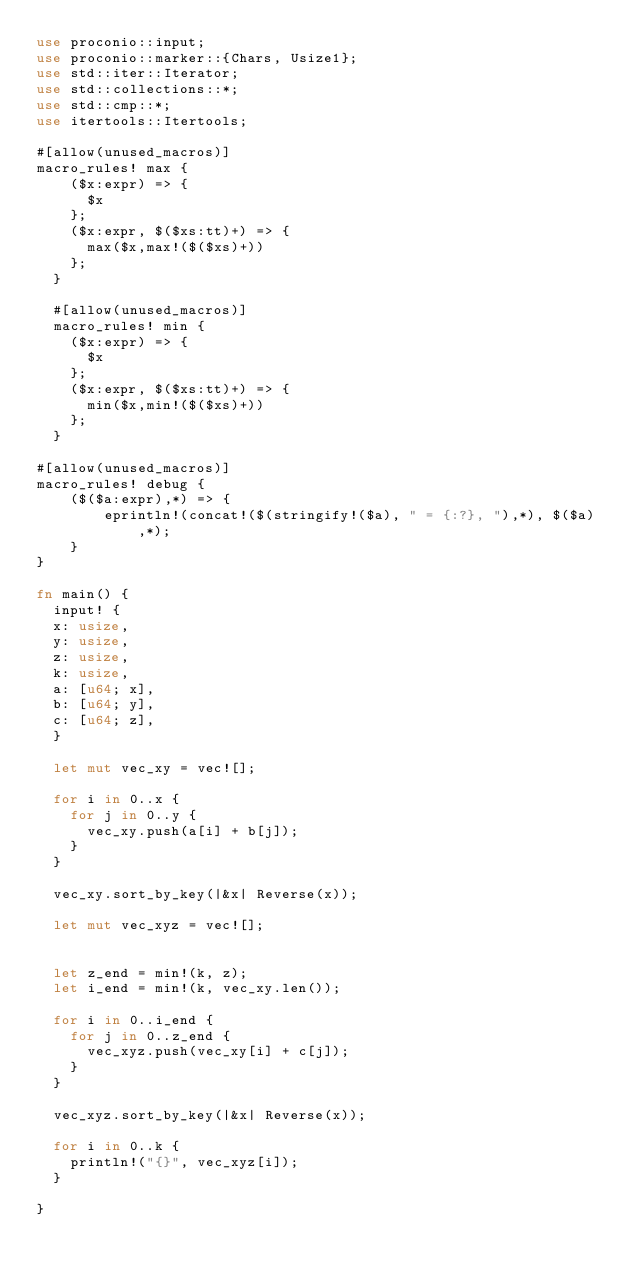Convert code to text. <code><loc_0><loc_0><loc_500><loc_500><_Rust_>use proconio::input;
use proconio::marker::{Chars, Usize1};
use std::iter::Iterator;
use std::collections::*;
use std::cmp::*;
use itertools::Itertools;

#[allow(unused_macros)]
macro_rules! max {
    ($x:expr) => {
      $x
    };
    ($x:expr, $($xs:tt)+) => {
      max($x,max!($($xs)+))
    };
  }
  
  #[allow(unused_macros)]
  macro_rules! min {
    ($x:expr) => {
      $x
    };
    ($x:expr, $($xs:tt)+) => {
      min($x,min!($($xs)+))
    };
  }

#[allow(unused_macros)]
macro_rules! debug {
    ($($a:expr),*) => {
        eprintln!(concat!($(stringify!($a), " = {:?}, "),*), $($a),*);
    }
}

fn main() {
  input! {
  x: usize,
  y: usize,
  z: usize,
  k: usize,
  a: [u64; x],
  b: [u64; y],
  c: [u64; z],
  }

  let mut vec_xy = vec![];

  for i in 0..x {
    for j in 0..y {
      vec_xy.push(a[i] + b[j]);
    }
  }

  vec_xy.sort_by_key(|&x| Reverse(x));

  let mut vec_xyz = vec![];


  let z_end = min!(k, z);
  let i_end = min!(k, vec_xy.len());

  for i in 0..i_end {
    for j in 0..z_end {
      vec_xyz.push(vec_xy[i] + c[j]);
    }
  }

  vec_xyz.sort_by_key(|&x| Reverse(x));

  for i in 0..k {
    println!("{}", vec_xyz[i]);
  }

}
</code> 